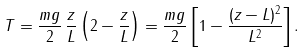Convert formula to latex. <formula><loc_0><loc_0><loc_500><loc_500>T = \frac { m g } { 2 } \, \frac { z } { L } \left ( 2 - \frac { z } { L } \right ) = \frac { m g } { 2 } \left [ 1 - \frac { ( z - L ) ^ { 2 } } { L ^ { 2 } } \right ] .</formula> 